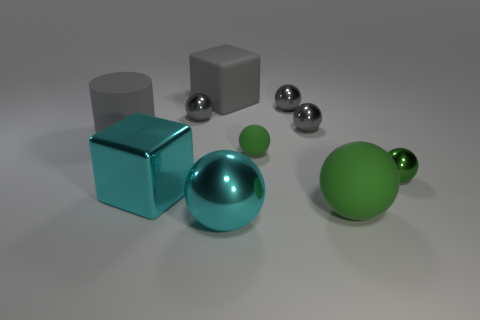Are there more rubber cubes than tiny red balls?
Provide a short and direct response. Yes. How many metal things are gray cylinders or small cyan cylinders?
Give a very brief answer. 0. How many tiny shiny things are the same color as the large metallic cube?
Offer a terse response. 0. There is a cyan object that is behind the big cyan metal sphere that is to the right of the big cyan metallic cube that is on the left side of the tiny green matte ball; what is it made of?
Offer a very short reply. Metal. What color is the shiny sphere to the left of the big cyan shiny thing in front of the big green rubber object?
Ensure brevity in your answer.  Gray. How many large objects are gray matte objects or shiny blocks?
Give a very brief answer. 3. How many large cylinders are made of the same material as the big cyan cube?
Ensure brevity in your answer.  0. There is a gray sphere that is on the left side of the big cyan sphere; how big is it?
Give a very brief answer. Small. What is the shape of the large rubber thing that is behind the gray cylinder that is on the left side of the gray rubber cube?
Your response must be concise. Cube. What number of blocks are on the left side of the large cyan thing in front of the large matte object in front of the green metallic ball?
Make the answer very short. 2. 